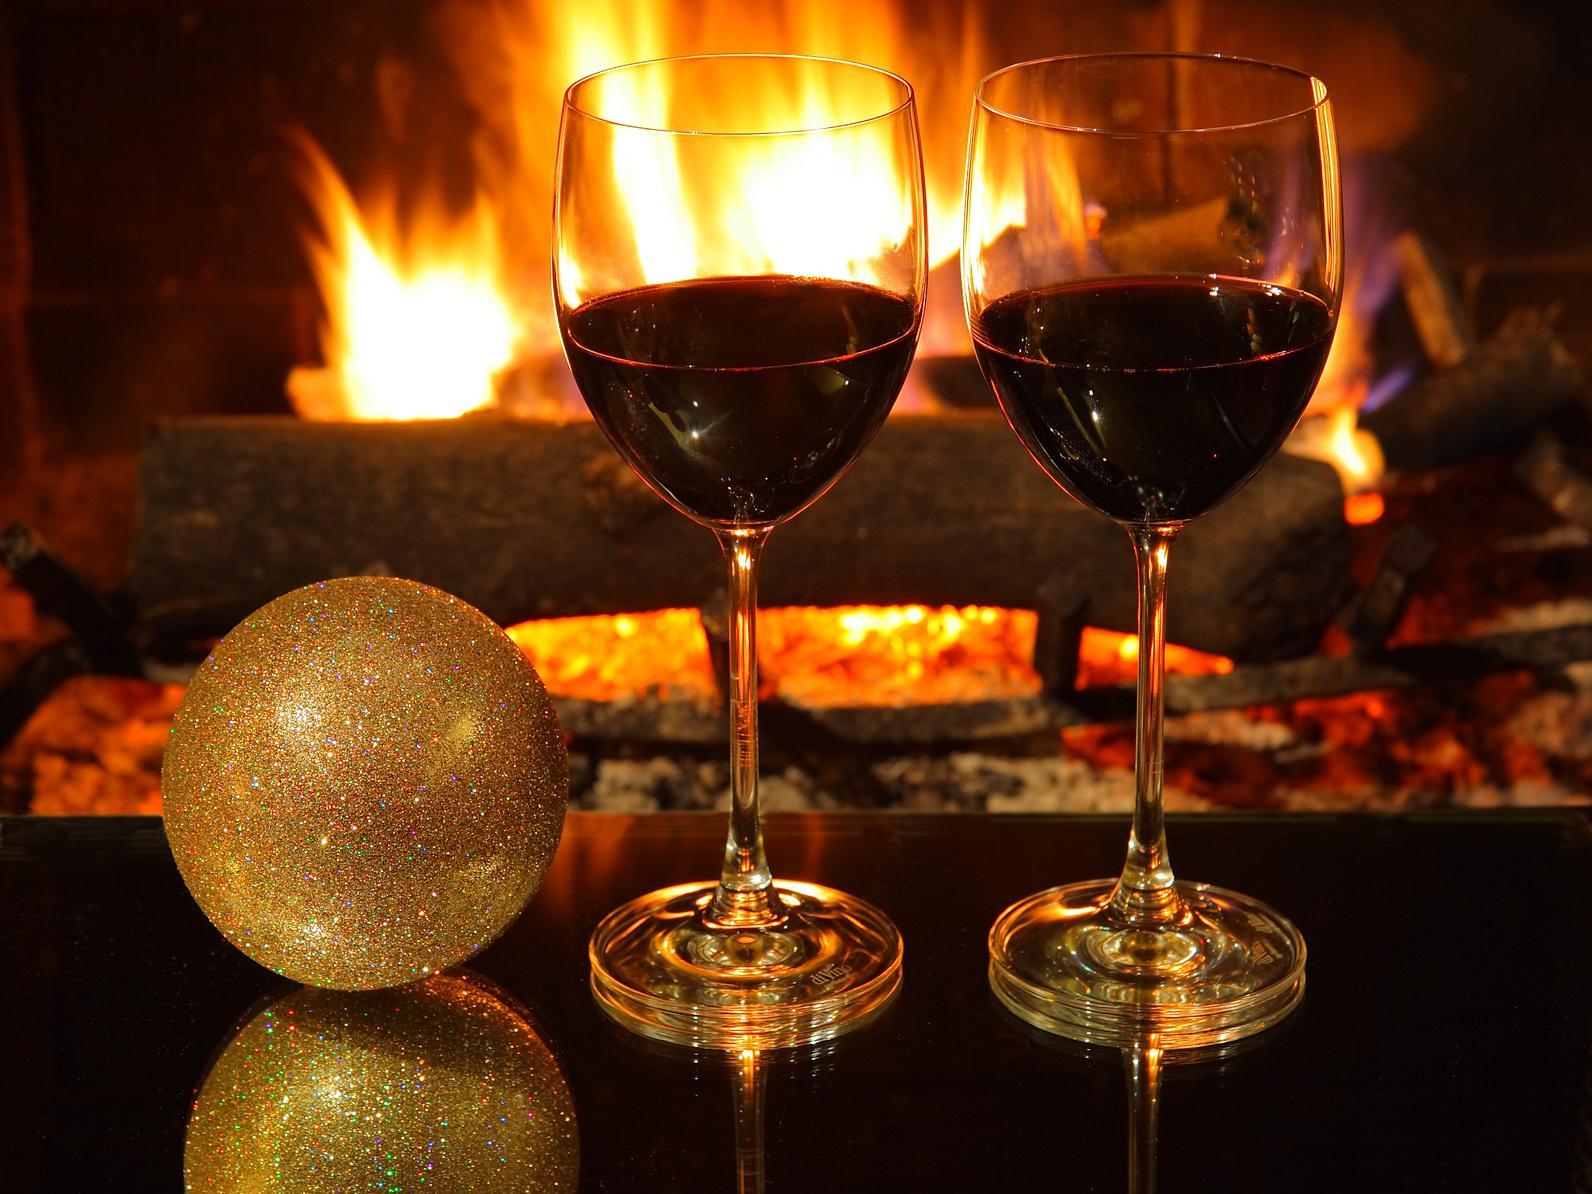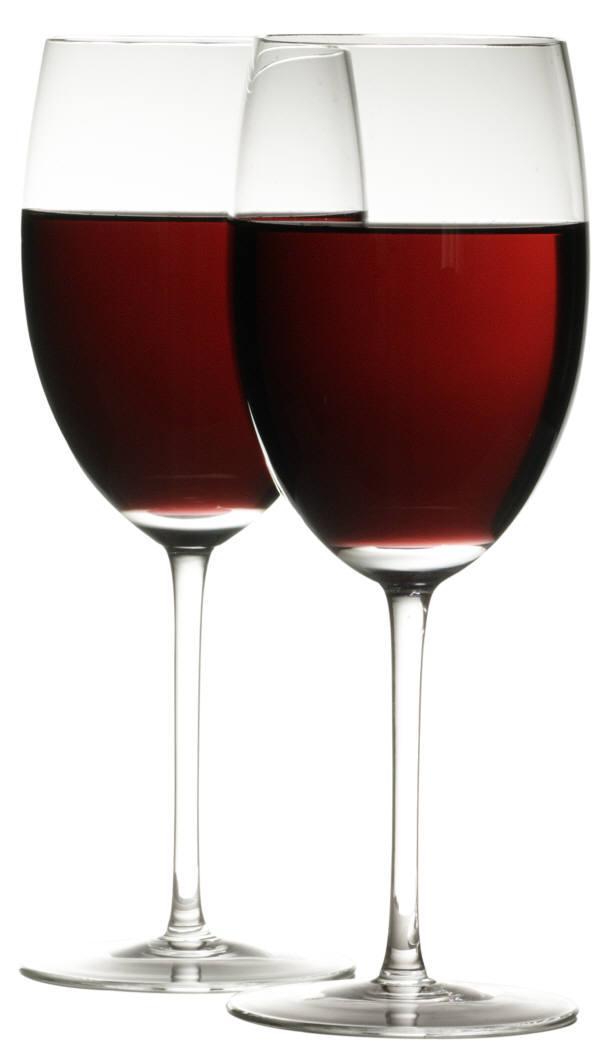The first image is the image on the left, the second image is the image on the right. Given the left and right images, does the statement "A hearth fire is visible in the background behind two glasses of dark red wine." hold true? Answer yes or no. Yes. The first image is the image on the left, the second image is the image on the right. For the images shown, is this caption "A wine bottle is near two wine glasses in at least one of the images." true? Answer yes or no. No. 